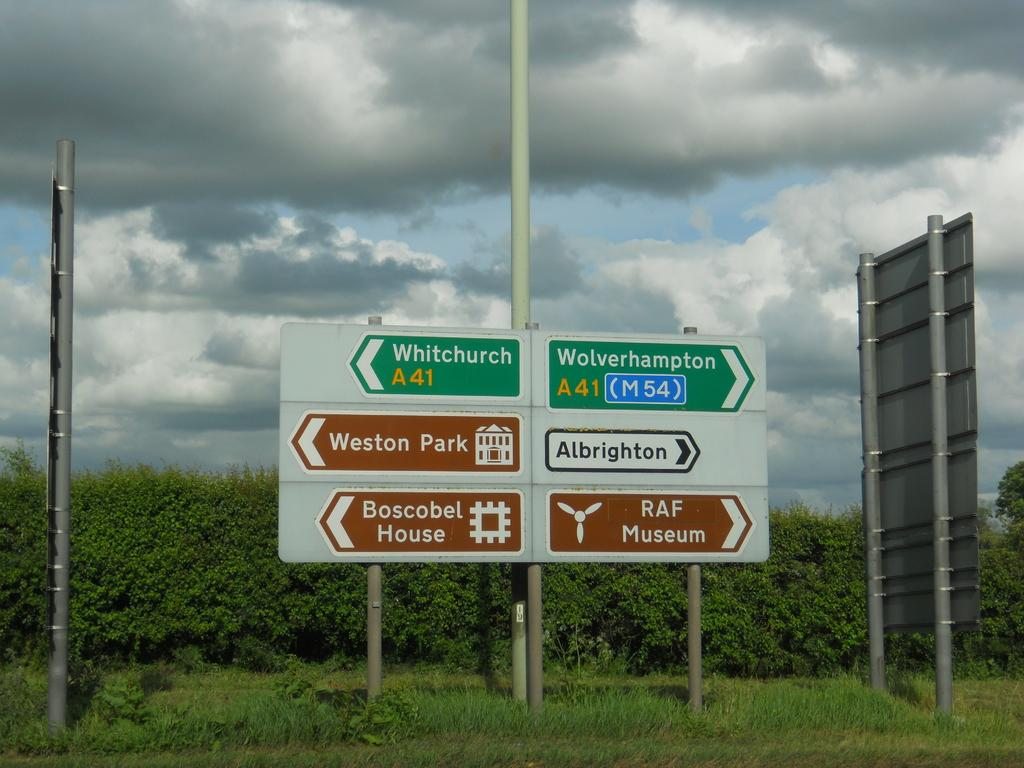<image>
Provide a brief description of the given image. Signs on the highway in England direct motorists to their destinations. 